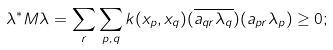<formula> <loc_0><loc_0><loc_500><loc_500>\lambda ^ { * } M \lambda = \sum _ { r } \sum _ { p , q } k ( x _ { p } , x _ { q } ) ( \overline { a _ { q r } \lambda _ { q } } ) ( a _ { p r } \lambda _ { p } ) \geq 0 ;</formula> 